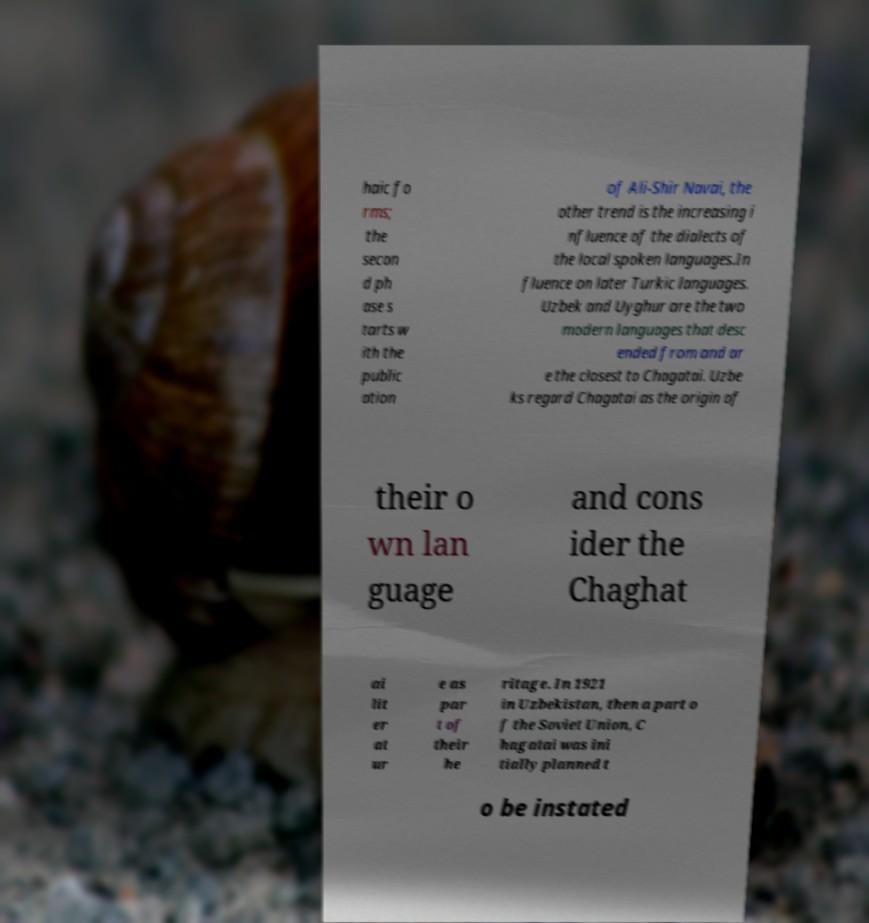Please identify and transcribe the text found in this image. haic fo rms; the secon d ph ase s tarts w ith the public ation of Ali-Shir Navai, the other trend is the increasing i nfluence of the dialects of the local spoken languages.In fluence on later Turkic languages. Uzbek and Uyghur are the two modern languages that desc ended from and ar e the closest to Chagatai. Uzbe ks regard Chagatai as the origin of their o wn lan guage and cons ider the Chaghat ai lit er at ur e as par t of their he ritage. In 1921 in Uzbekistan, then a part o f the Soviet Union, C hagatai was ini tially planned t o be instated 